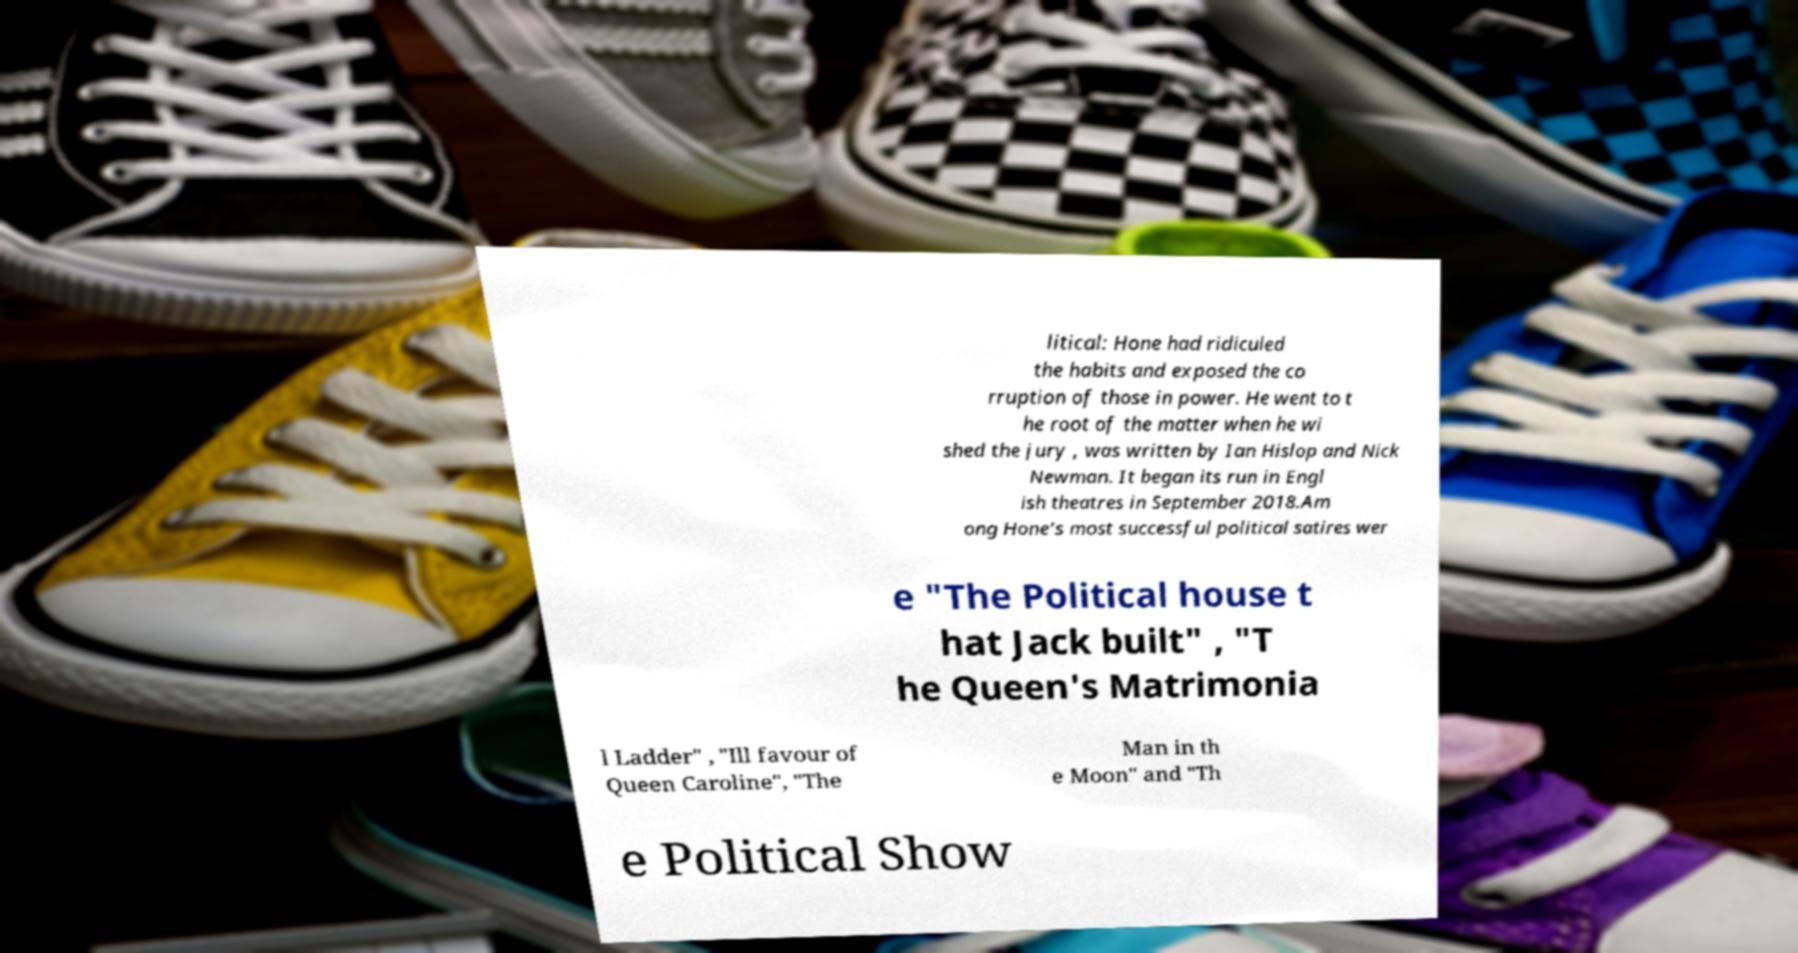There's text embedded in this image that I need extracted. Can you transcribe it verbatim? litical: Hone had ridiculed the habits and exposed the co rruption of those in power. He went to t he root of the matter when he wi shed the jury , was written by Ian Hislop and Nick Newman. It began its run in Engl ish theatres in September 2018.Am ong Hone's most successful political satires wer e "The Political house t hat Jack built" , "T he Queen's Matrimonia l Ladder" , "Ill favour of Queen Caroline", "The Man in th e Moon" and "Th e Political Show 